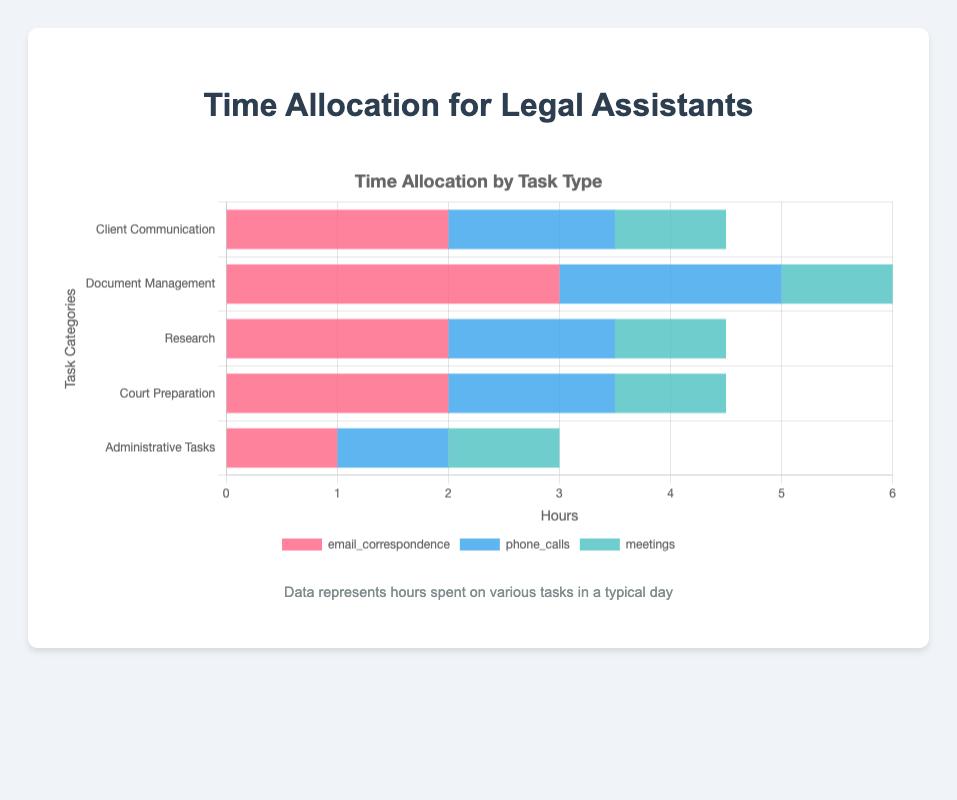What is the total time spent on client communication tasks? Client communication tasks include email correspondence (2 hours), phone calls (1.5 hours), and meetings (1 hour). Summing them up: 2 + 1.5 + 1 = 4.5 hours
Answer: 4.5 hours Which task consumes the most amount of time within the document management category? The document management category includes drafting documents (3 hours), reviewing documents (2 hours), and filing documents (1 hour). Drafting documents consumes the most time with 3 hours
Answer: Drafting documents Comparing legal research and case analysis, which task is allocated more time? Legal research is allocated 2 hours while case analysis is allocated 1.5 hours. Thus, legal research is allocated more time
Answer: Legal research How much more time is spent on drafting documents compared to preparing briefs? Drafting documents takes 3 hours, and preparing briefs takes 2 hours. The difference is 3 - 2 = 1 hour
Answer: 1 hour Which administrative task is allocated the least time, and how many hours is it? Administrative tasks include scheduling appointments (1 hour), billing (1 hour), and office management (1 hour). All tasks are allocated equal time of 1 hour, so there is no least time
Answer: All tasks, 1 hour What is the total time spent on research tasks in a typical day? Research tasks include legal research (2 hours), case analysis (1.5 hours), and statutory research (1 hour). Summing them up: 2 + 1.5 + 1 = 4.5 hours
Answer: 4.5 hours Which task category has the most diversified time allocation (i.e., largest difference between the highest and lowest values)? Document management has the most diversified time allocation with 3 hours for drafting documents, 2 hours for reviewing documents, and 1 hour for filing documents. The largest difference is 3 - 1 = 2 hours
Answer: Document management In the court preparation category, prepare a visual comparison between the time allocated to compiling evidence and preparing witnesses. Compiling evidence is allocated 1.5 hours and preparing witnesses 1 hour. Visually, the bar representing compiling evidence would be longer compared to that for preparing witnesses
Answer: Compiling evidence > Preparing witnesses What is the average time spent on administrative tasks? Administrative tasks include scheduling appointments (1 hour), billing (1 hour), and office management (1 hour). The average time is (1 + 1 + 1) / 3 = 3 / 3 = 1 hour
Answer: 1 hour How much total time is spent on preparing briefs and legal research combined? Time spent on preparing briefs is 2 hours and on legal research is 2 hours. Summing them up: 2 + 2 = 4 hours
Answer: 4 hours 